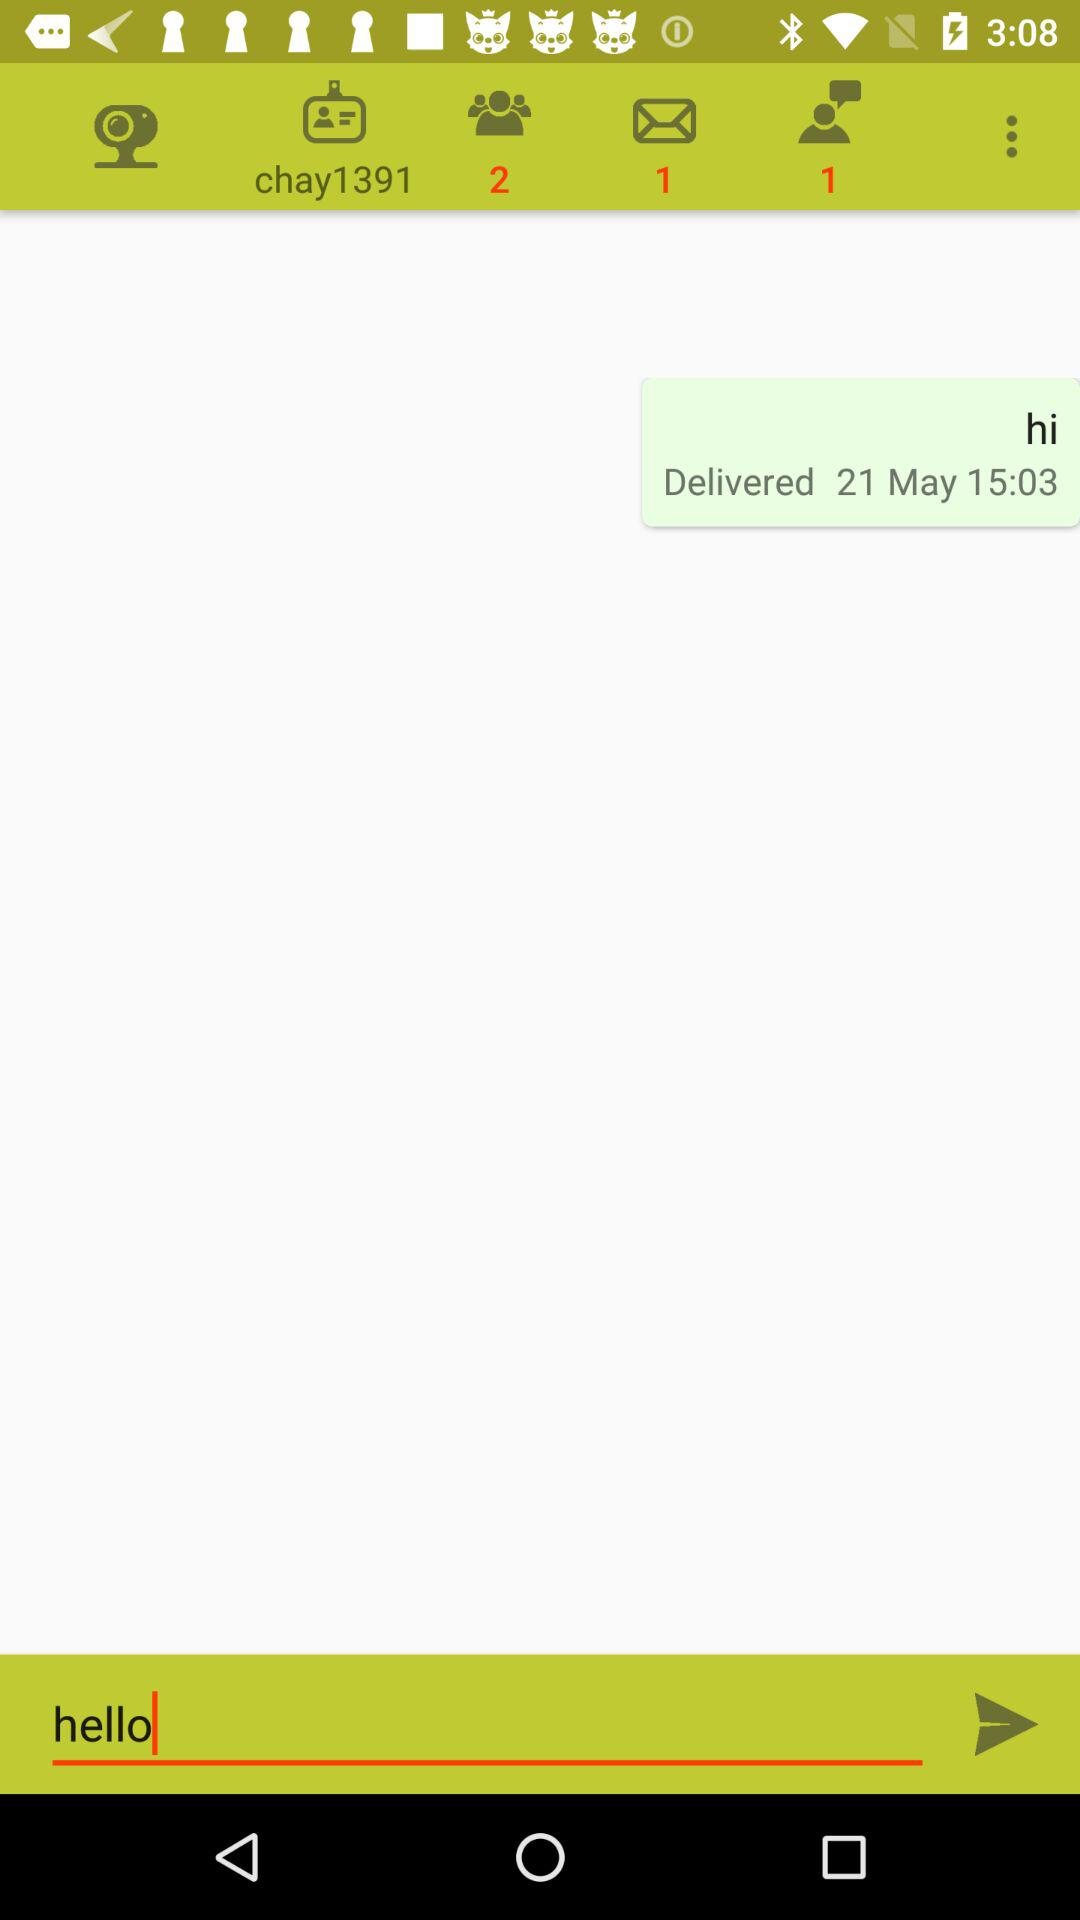Are there any unread messages? There is only 1 unread message. 